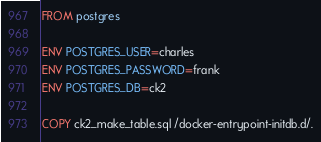<code> <loc_0><loc_0><loc_500><loc_500><_Dockerfile_>FROM postgres

ENV POSTGRES_USER=charles
ENV POSTGRES_PASSWORD=frank
ENV POSTGRES_DB=ck2

COPY ck2_make_table.sql /docker-entrypoint-initdb.d/.


</code> 